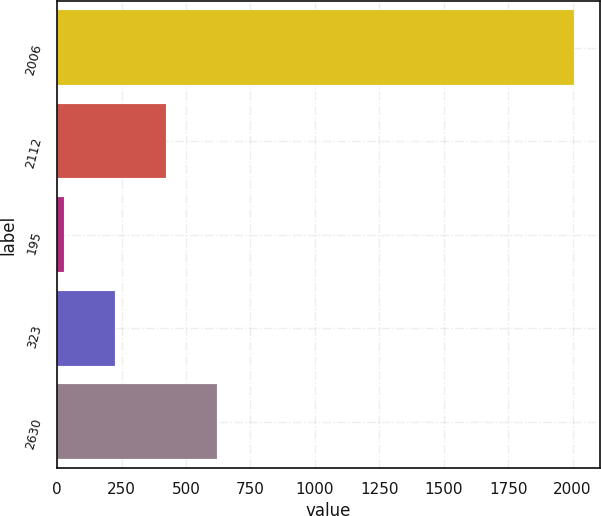Convert chart to OTSL. <chart><loc_0><loc_0><loc_500><loc_500><bar_chart><fcel>2006<fcel>2112<fcel>195<fcel>323<fcel>2630<nl><fcel>2005<fcel>420.76<fcel>24.7<fcel>222.73<fcel>618.79<nl></chart> 